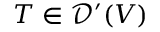<formula> <loc_0><loc_0><loc_500><loc_500>T \in { \mathcal { D } } ^ { \prime } ( V )</formula> 